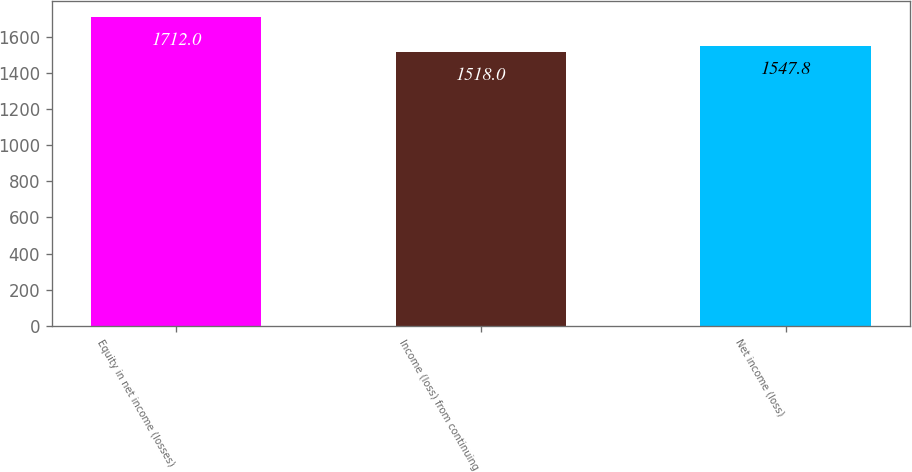Convert chart to OTSL. <chart><loc_0><loc_0><loc_500><loc_500><bar_chart><fcel>Equity in net income (losses)<fcel>Income (loss) from continuing<fcel>Net income (loss)<nl><fcel>1712<fcel>1518<fcel>1547.8<nl></chart> 